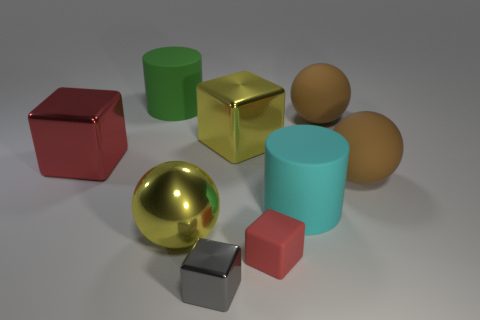There is a rubber cylinder on the left side of the large cyan thing; does it have the same color as the tiny metal object?
Your answer should be very brief. No. What number of big cyan matte objects are the same shape as the tiny gray thing?
Make the answer very short. 0. How many things are either metallic objects behind the tiny red matte block or large rubber things that are to the right of the large metal ball?
Keep it short and to the point. 6. What number of gray objects are small metal objects or small rubber things?
Give a very brief answer. 1. What is the sphere that is both to the right of the large yellow cube and in front of the large red metallic thing made of?
Offer a terse response. Rubber. Is the material of the cyan cylinder the same as the green cylinder?
Provide a short and direct response. Yes. What number of brown things have the same size as the red shiny block?
Your answer should be compact. 2. Are there the same number of objects to the left of the tiny gray metallic block and big shiny things?
Your answer should be very brief. Yes. What number of objects are both in front of the yellow block and to the left of the cyan rubber cylinder?
Offer a terse response. 4. Is the shape of the big metal thing on the right side of the gray thing the same as  the small metal thing?
Offer a very short reply. Yes. 